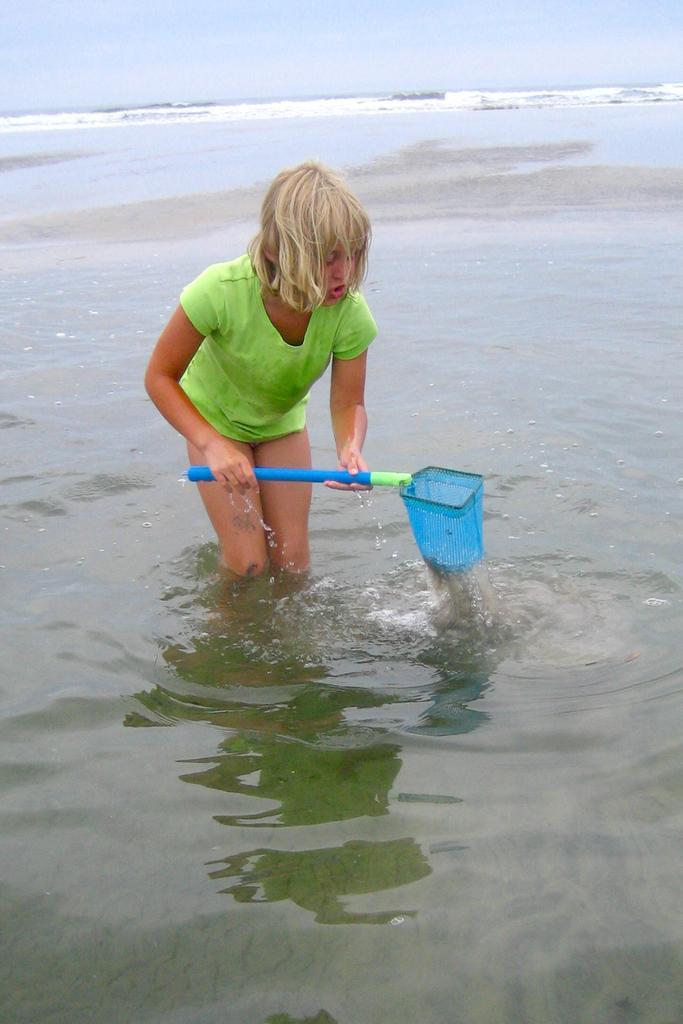Can you describe this image briefly? In this image I can see a woman holding a stick and standing on water and at the top I can see the sky. 